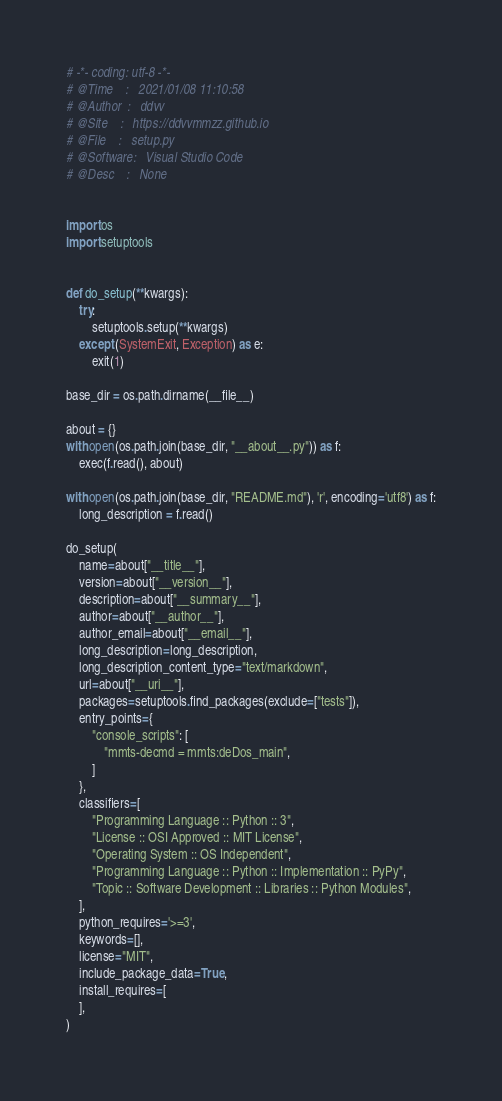Convert code to text. <code><loc_0><loc_0><loc_500><loc_500><_Python_># -*- coding: utf-8 -*-
# @Time    :   2021/01/08 11:10:58
# @Author  :   ddvv
# @Site    :   https://ddvvmmzz.github.io
# @File    :   setup.py
# @Software:   Visual Studio Code
# @Desc    :   None


import os
import setuptools


def do_setup(**kwargs):
    try:
        setuptools.setup(**kwargs)
    except (SystemExit, Exception) as e:
        exit(1)

base_dir = os.path.dirname(__file__)

about = {}
with open(os.path.join(base_dir, "__about__.py")) as f:
    exec(f.read(), about)

with open(os.path.join(base_dir, "README.md"), 'r', encoding='utf8') as f:
    long_description = f.read()

do_setup(
    name=about["__title__"],
    version=about["__version__"],
    description=about["__summary__"],
    author=about["__author__"],
    author_email=about["__email__"],
    long_description=long_description,
    long_description_content_type="text/markdown",
    url=about["__uri__"],
    packages=setuptools.find_packages(exclude=["tests"]),
    entry_points={
        "console_scripts": [
            "mmts-decmd = mmts:deDos_main",
        ]
    },
    classifiers=[
        "Programming Language :: Python :: 3",
        "License :: OSI Approved :: MIT License",
        "Operating System :: OS Independent",
        "Programming Language :: Python :: Implementation :: PyPy",
        "Topic :: Software Development :: Libraries :: Python Modules",
    ],
    python_requires='>=3',
    keywords=[],
    license="MIT",
    include_package_data=True,
    install_requires=[
    ],
)
</code> 